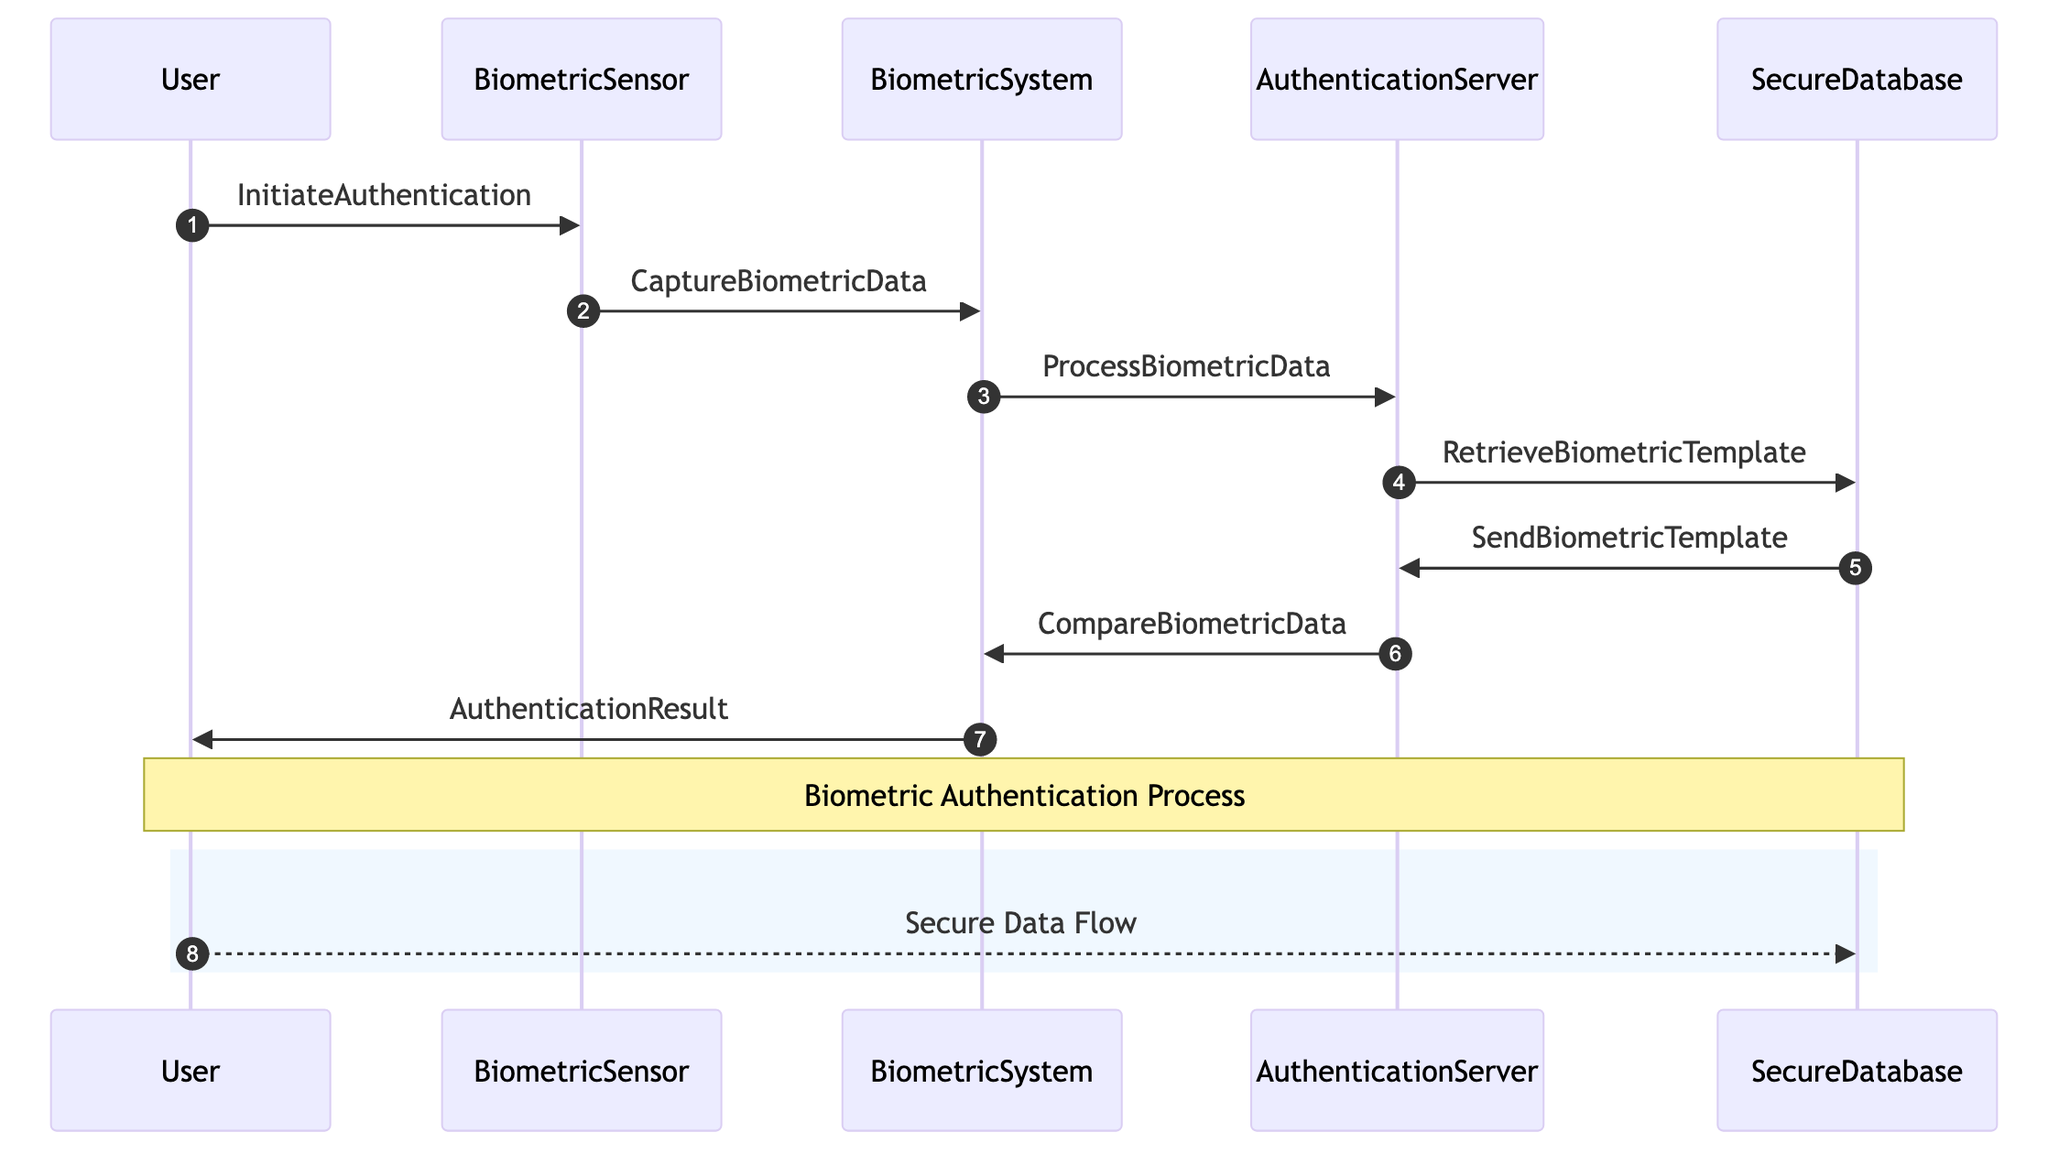What is the first action taken by the User? The diagram shows that the first action taken by the User is to send "InitiateAuthentication" to the BiometricSensor.
Answer: InitiateAuthentication How many participants are involved in the authentication process? The diagram lists five participants: User, BiometricSensor, BiometricSystem, AuthenticationServer, and SecureDatabase.
Answer: 5 What does the BiometricSensor do after capturing biometric data? After capturing biometric data, the BiometricSensor sends "CaptureBiometricData" to the BiometricSystem for processing.
Answer: CaptureBiometricData What information does the AuthenticationServer retrieve from the SecureDatabase? The AuthenticationServer retrieves the "BiometricTemplate" from the SecureDatabase for comparison with the captured data.
Answer: BiometricTemplate What is the last message sent in the sequence? The last message in the sequence is the "AuthenticationResult" sent from the BiometricSystem to the User, informing them of the authentication outcome.
Answer: AuthenticationResult What is the purpose of the note in the diagram? The note provides clarification that the process being depicted is referred to as the "Biometric Authentication Process."
Answer: Biometric Authentication Process How does the User receive the outcome of their authentication attempt? The User receives the authentication outcome through the message "AuthenticationResult" from the BiometricSystem.
Answer: AuthenticationResult Which component compares the processed biometric data with the biometric template? The AuthenticationServer is responsible for comparing the processed biometric data with the stored template for identity verification.
Answer: AuthenticationServer 